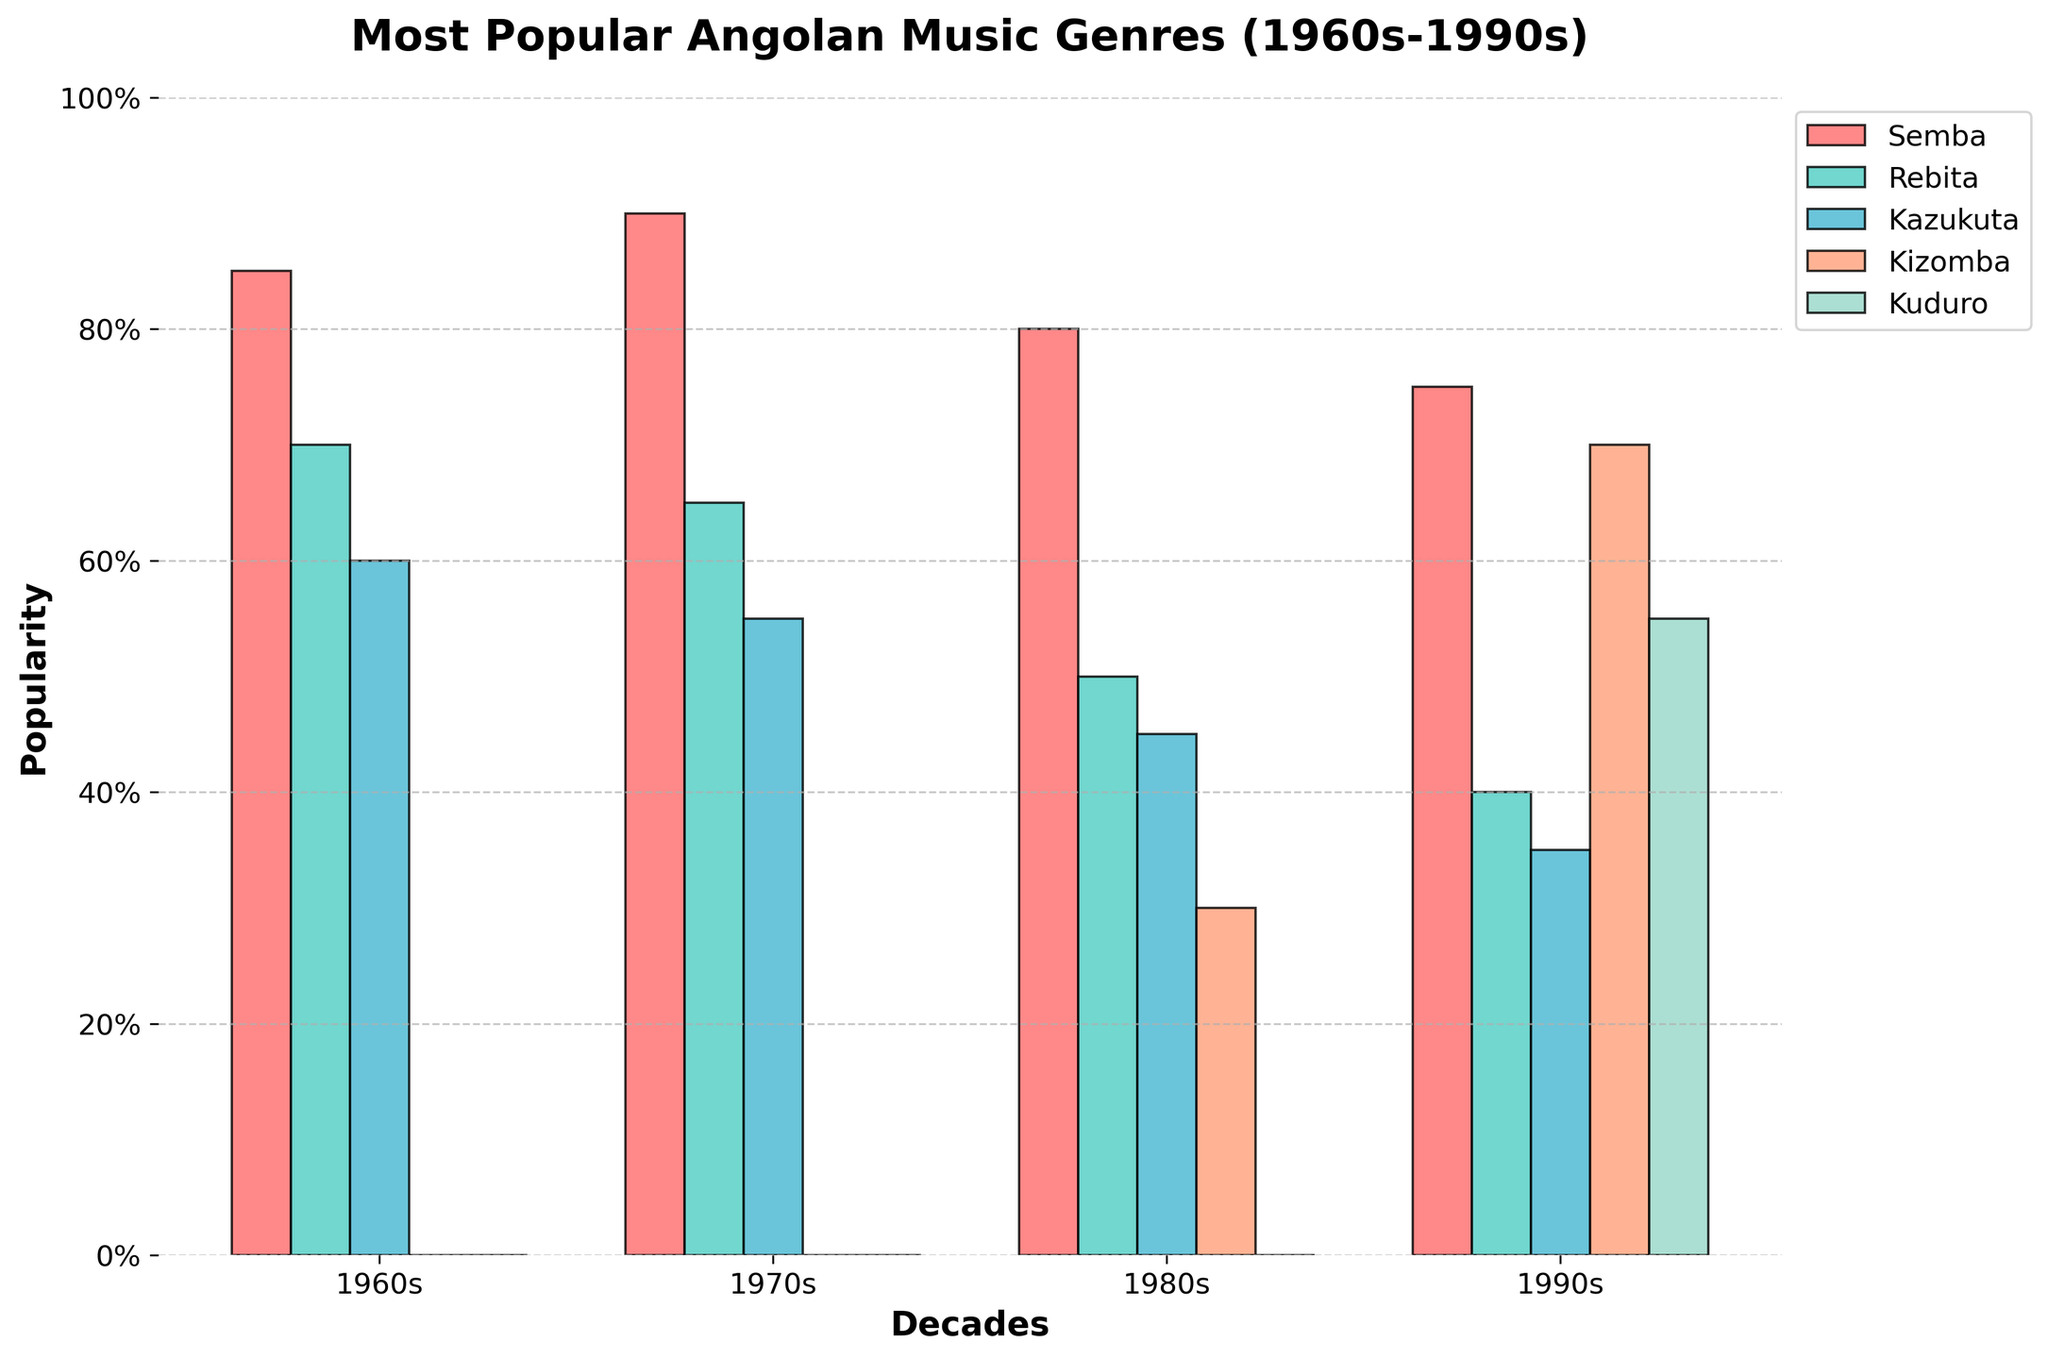Which genre was most popular in the 1980s? Semba has the highest bar among all the genres in the 1980s.
Answer: Semba Which decade did Kizomba first become popular? The bar for Kizomba in the 1980s shows a value of 30; it's 0 in all previous decades.
Answer: 1980s Which genres saw an increase in popularity from the 1960s to the 1990s? Comparing the heights of the bars from the 1960s to the 1990s, Kizomba and Kuduro both have higher values in the 1990s.
Answer: Kizomba, Kuduro By how much did the popularity of Semba decrease from the 1970s to the 1990s? The Semba bar in the 1970s shows a value of 90, and in the 1990s it is 75. The difference between these values is 90 - 75.
Answer: 15 Which genre had the least popularity in the 1990s? The bar for Rebita in the 1990s is the shortest, corresponding to a value of 40.
Answer: Rebita What is the average popularity of Semba across all decades? Add the values of Semba for each decade: 85 + 90 + 80 + 75 = 330. Divide by the number of decades (4).
Answer: 82.5 How does the popularity of Kazukuta in the 1980s compare to Kuduro in the same decade? The Kazukuta bar in the 1980s is higher than the Kuduro bar, which has a value of 0. Kazukuta has a value of 45.
Answer: Kazukuta is more popular Which genre shows a sudden increase in popularity in the 1990s? Kuduro's bar height jumps to 55 in the 1990s from 0 in all previous decades.
Answer: Kuduro What is the total popularity of all genres in the 1970s? Sum the values for all genres in the 1970s: 90 (Semba) + 65 (Rebita) + 55 (Kazukuta) + 0 (Kizomba) + 0 (Kuduro).
Answer: 210 